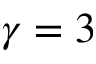<formula> <loc_0><loc_0><loc_500><loc_500>\gamma = 3</formula> 